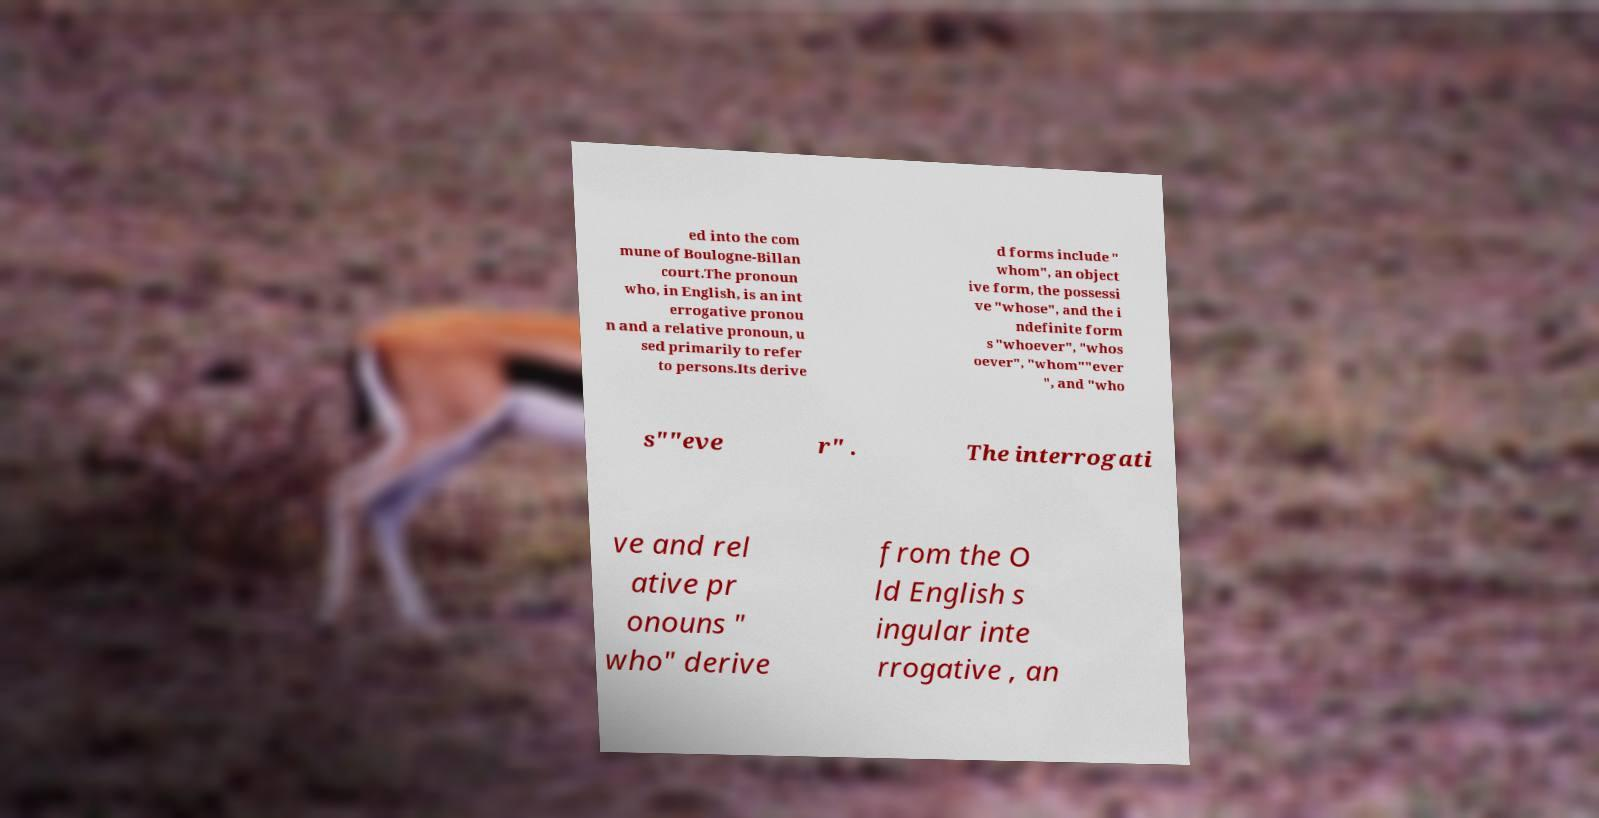I need the written content from this picture converted into text. Can you do that? ed into the com mune of Boulogne-Billan court.The pronoun who, in English, is an int errogative pronou n and a relative pronoun, u sed primarily to refer to persons.Its derive d forms include " whom", an object ive form, the possessi ve "whose", and the i ndefinite form s "whoever", "whos oever", "whom""ever ", and "who s""eve r" . The interrogati ve and rel ative pr onouns " who" derive from the O ld English s ingular inte rrogative , an 